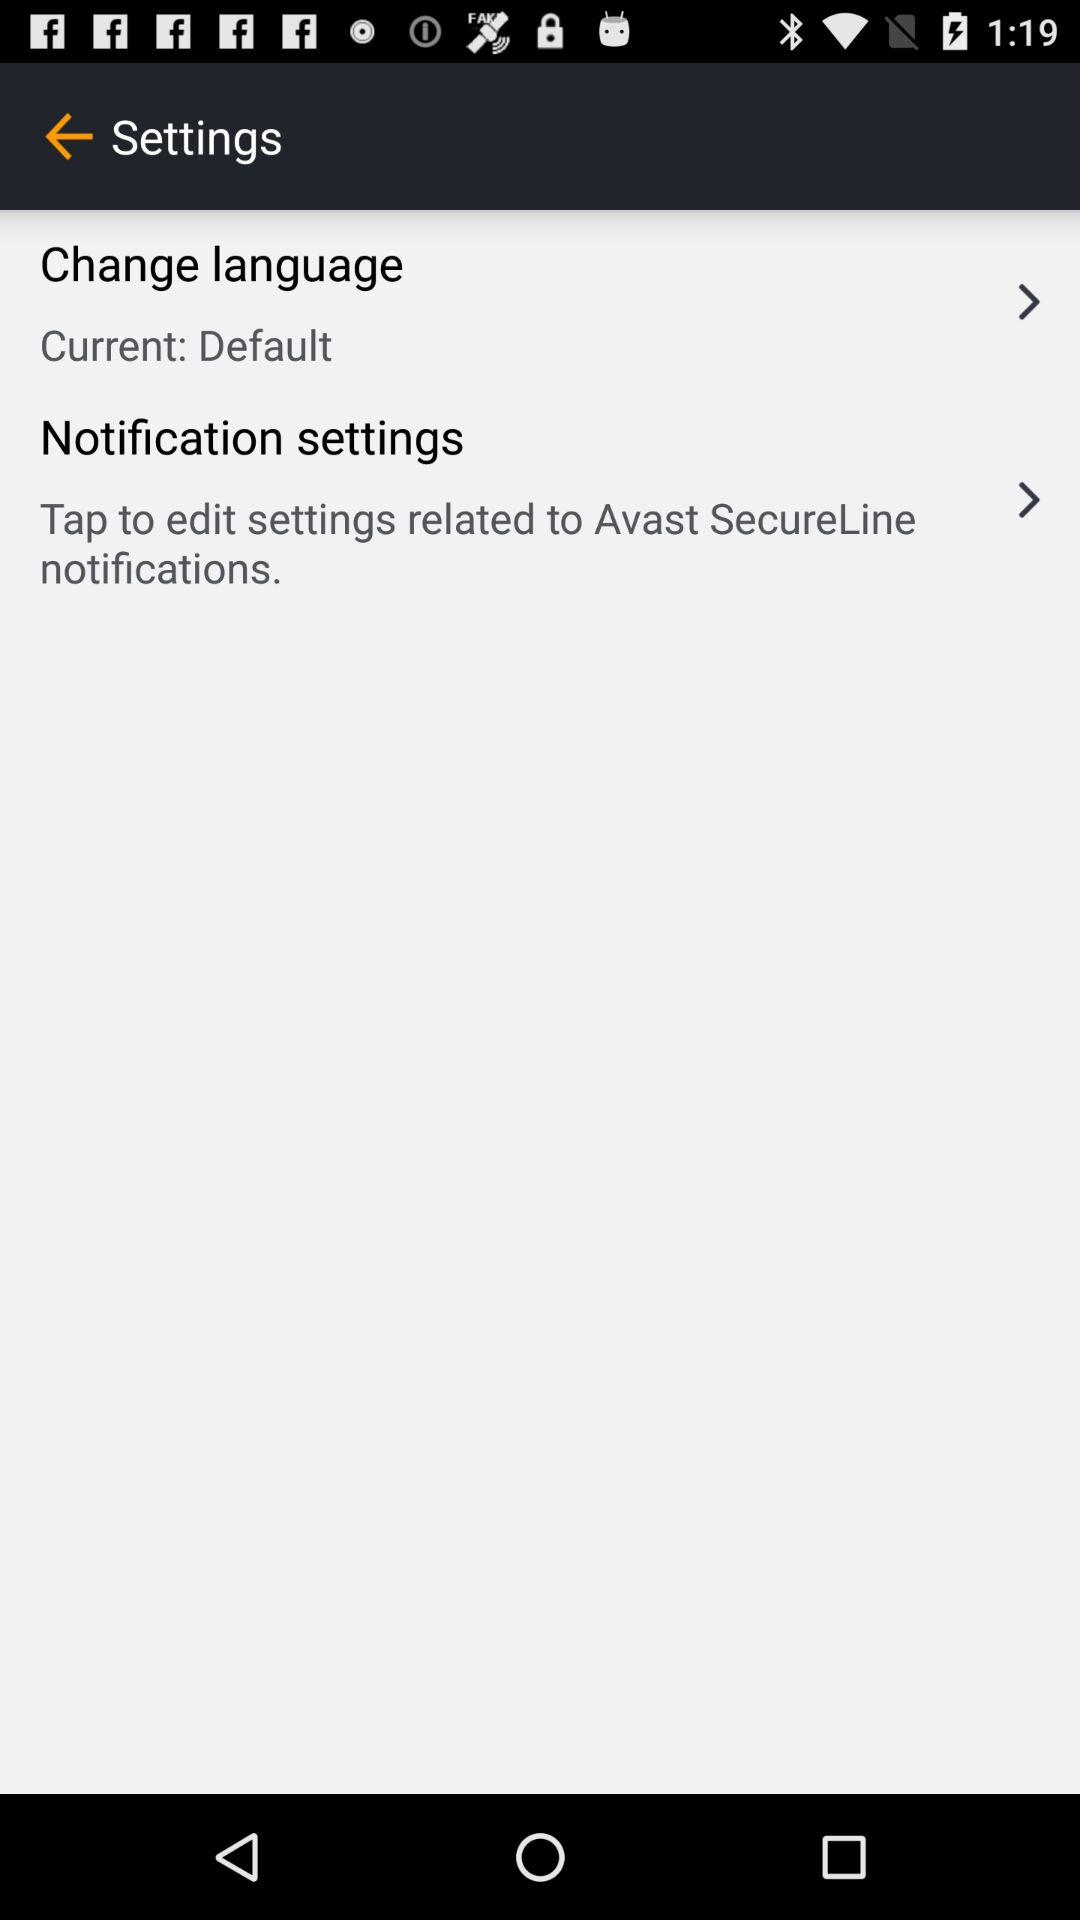What is the current language? The current language is "Default". 